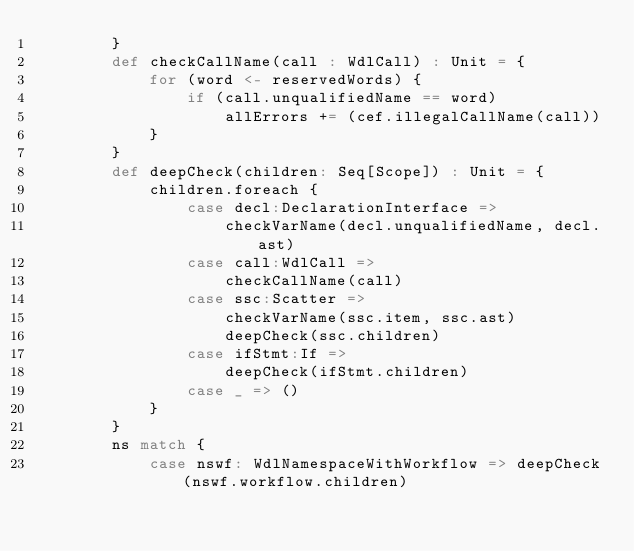<code> <loc_0><loc_0><loc_500><loc_500><_Scala_>        }
        def checkCallName(call : WdlCall) : Unit = {
            for (word <- reservedWords) {
                if (call.unqualifiedName == word)
                    allErrors += (cef.illegalCallName(call))
            }
        }
        def deepCheck(children: Seq[Scope]) : Unit = {
            children.foreach {
                case decl:DeclarationInterface =>
                    checkVarName(decl.unqualifiedName, decl.ast)
                case call:WdlCall =>
                    checkCallName(call)
                case ssc:Scatter =>
                    checkVarName(ssc.item, ssc.ast)
                    deepCheck(ssc.children)
                case ifStmt:If =>
                    deepCheck(ifStmt.children)
                case _ => ()
            }
        }
        ns match {
            case nswf: WdlNamespaceWithWorkflow => deepCheck(nswf.workflow.children)</code> 